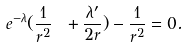Convert formula to latex. <formula><loc_0><loc_0><loc_500><loc_500>e ^ { - \lambda } ( \frac { 1 } { r ^ { 2 } } \ + \frac { { \lambda } ^ { \prime } } { 2 r } ) - \frac { 1 } { r ^ { 2 } } = 0 .</formula> 